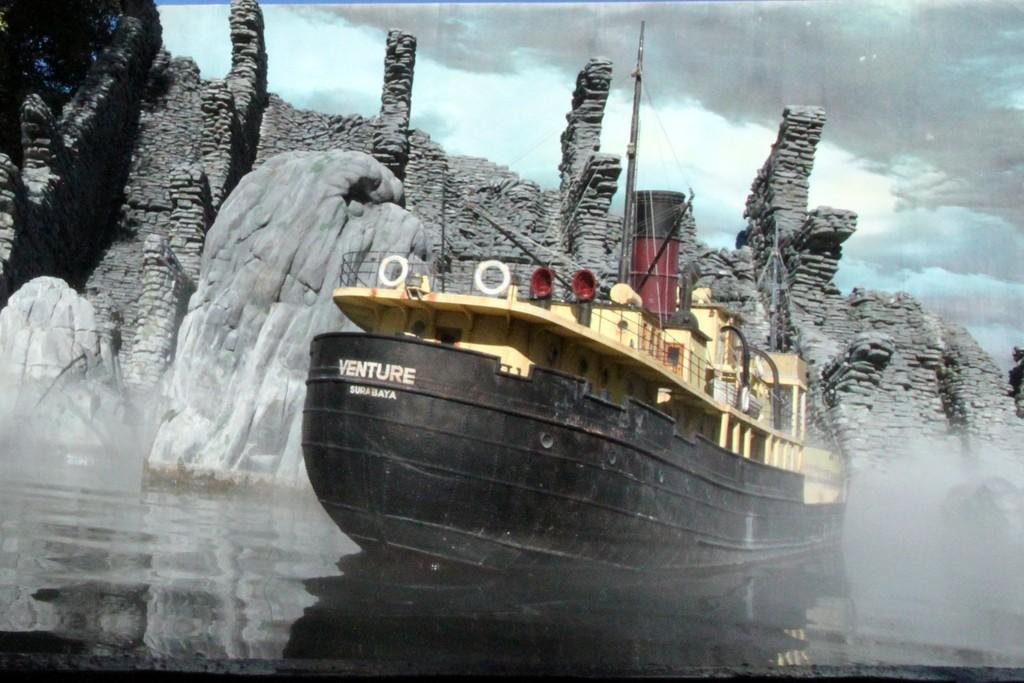What type of ship is in the image? There is a black color ship in the image. Where is the ship located? The ship is on the surface of water. What can be seen in the background of the image? There is a monument in the background of the image. How would you describe the sky in the image? The sky is covered with clouds. What type of cracker is floating on the water near the ship? There is no cracker present in the image; it only features a black color ship on the surface of water. Can you see any wires connecting the ship to the monument in the background? There are no wires visible in the image; it only shows a ship on the water and a monument in the background. 